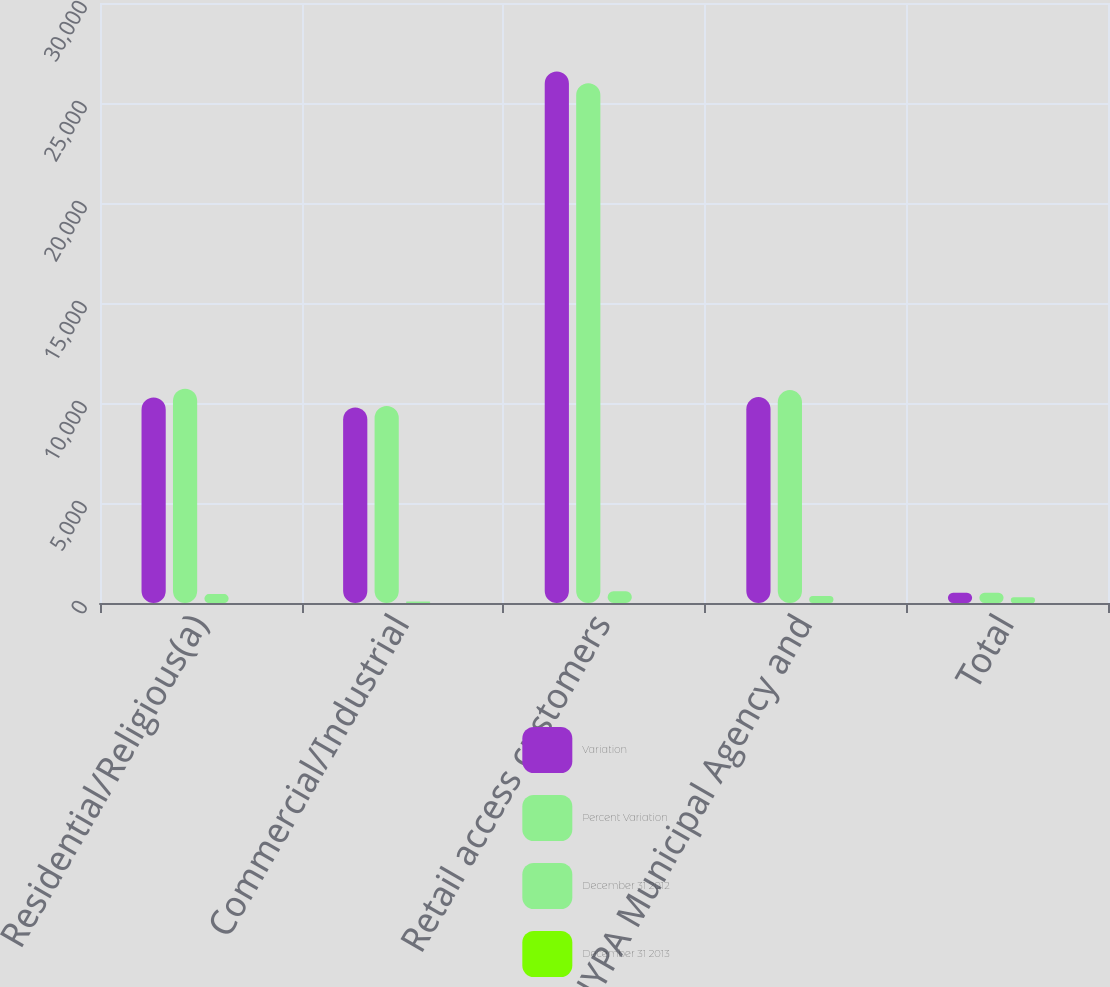Convert chart. <chart><loc_0><loc_0><loc_500><loc_500><stacked_bar_chart><ecel><fcel>Residential/Religious(a)<fcel>Commercial/Industrial<fcel>Retail access customers<fcel>NYPA Municipal Agency and<fcel>Total<nl><fcel>Variation<fcel>10273<fcel>9776<fcel>26574<fcel>10295<fcel>514.5<nl><fcel>Percent Variation<fcel>10718<fcel>9848<fcel>25990<fcel>10645<fcel>514.5<nl><fcel>December 31 2012<fcel>445<fcel>72<fcel>584<fcel>350<fcel>283<nl><fcel>December 31 2013<fcel>4.2<fcel>0.7<fcel>2.2<fcel>3.3<fcel>0.5<nl></chart> 